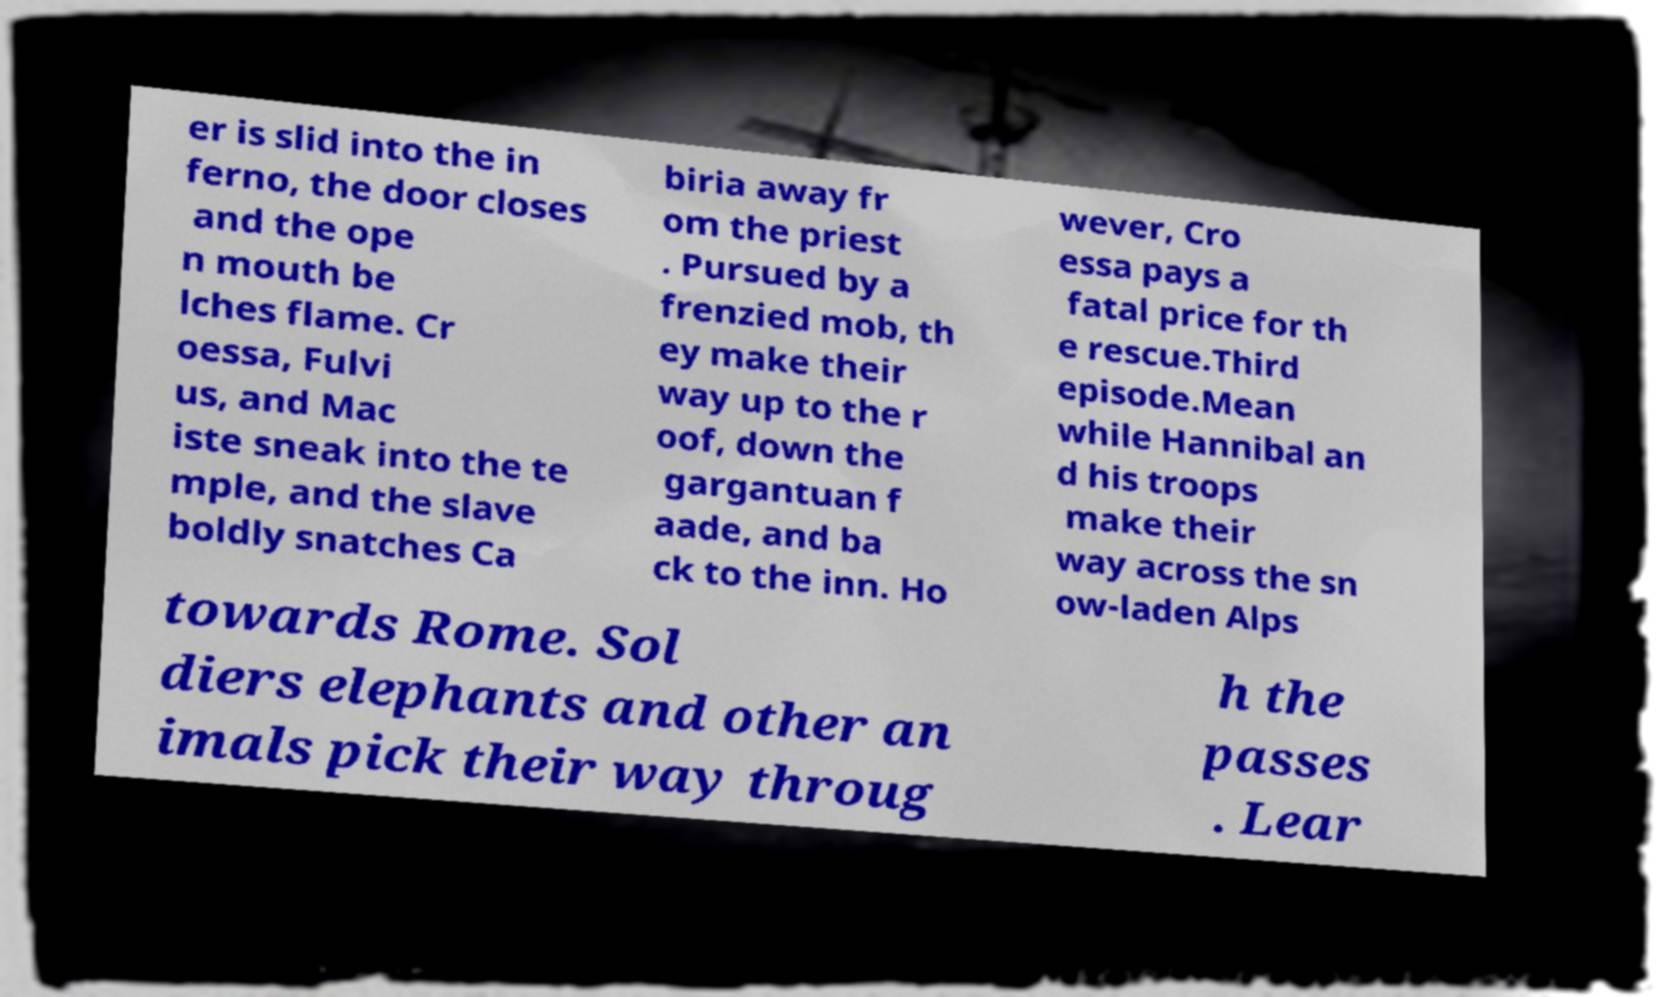There's text embedded in this image that I need extracted. Can you transcribe it verbatim? er is slid into the in ferno, the door closes and the ope n mouth be lches flame. Cr oessa, Fulvi us, and Mac iste sneak into the te mple, and the slave boldly snatches Ca biria away fr om the priest . Pursued by a frenzied mob, th ey make their way up to the r oof, down the gargantuan f aade, and ba ck to the inn. Ho wever, Cro essa pays a fatal price for th e rescue.Third episode.Mean while Hannibal an d his troops make their way across the sn ow-laden Alps towards Rome. Sol diers elephants and other an imals pick their way throug h the passes . Lear 